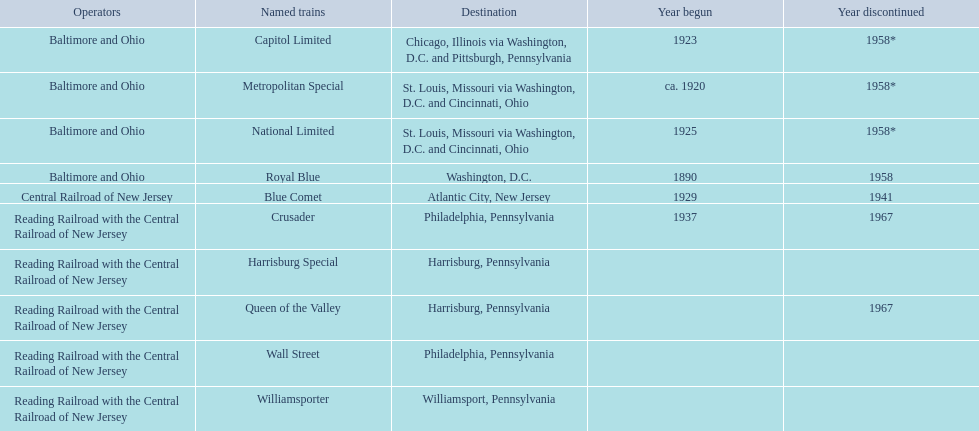What destinations are listed from the central railroad of new jersey terminal? Chicago, Illinois via Washington, D.C. and Pittsburgh, Pennsylvania, St. Louis, Missouri via Washington, D.C. and Cincinnati, Ohio, St. Louis, Missouri via Washington, D.C. and Cincinnati, Ohio, Washington, D.C., Atlantic City, New Jersey, Philadelphia, Pennsylvania, Harrisburg, Pennsylvania, Harrisburg, Pennsylvania, Philadelphia, Pennsylvania, Williamsport, Pennsylvania. Which of these destinations is listed first? Chicago, Illinois via Washington, D.C. and Pittsburgh, Pennsylvania. 